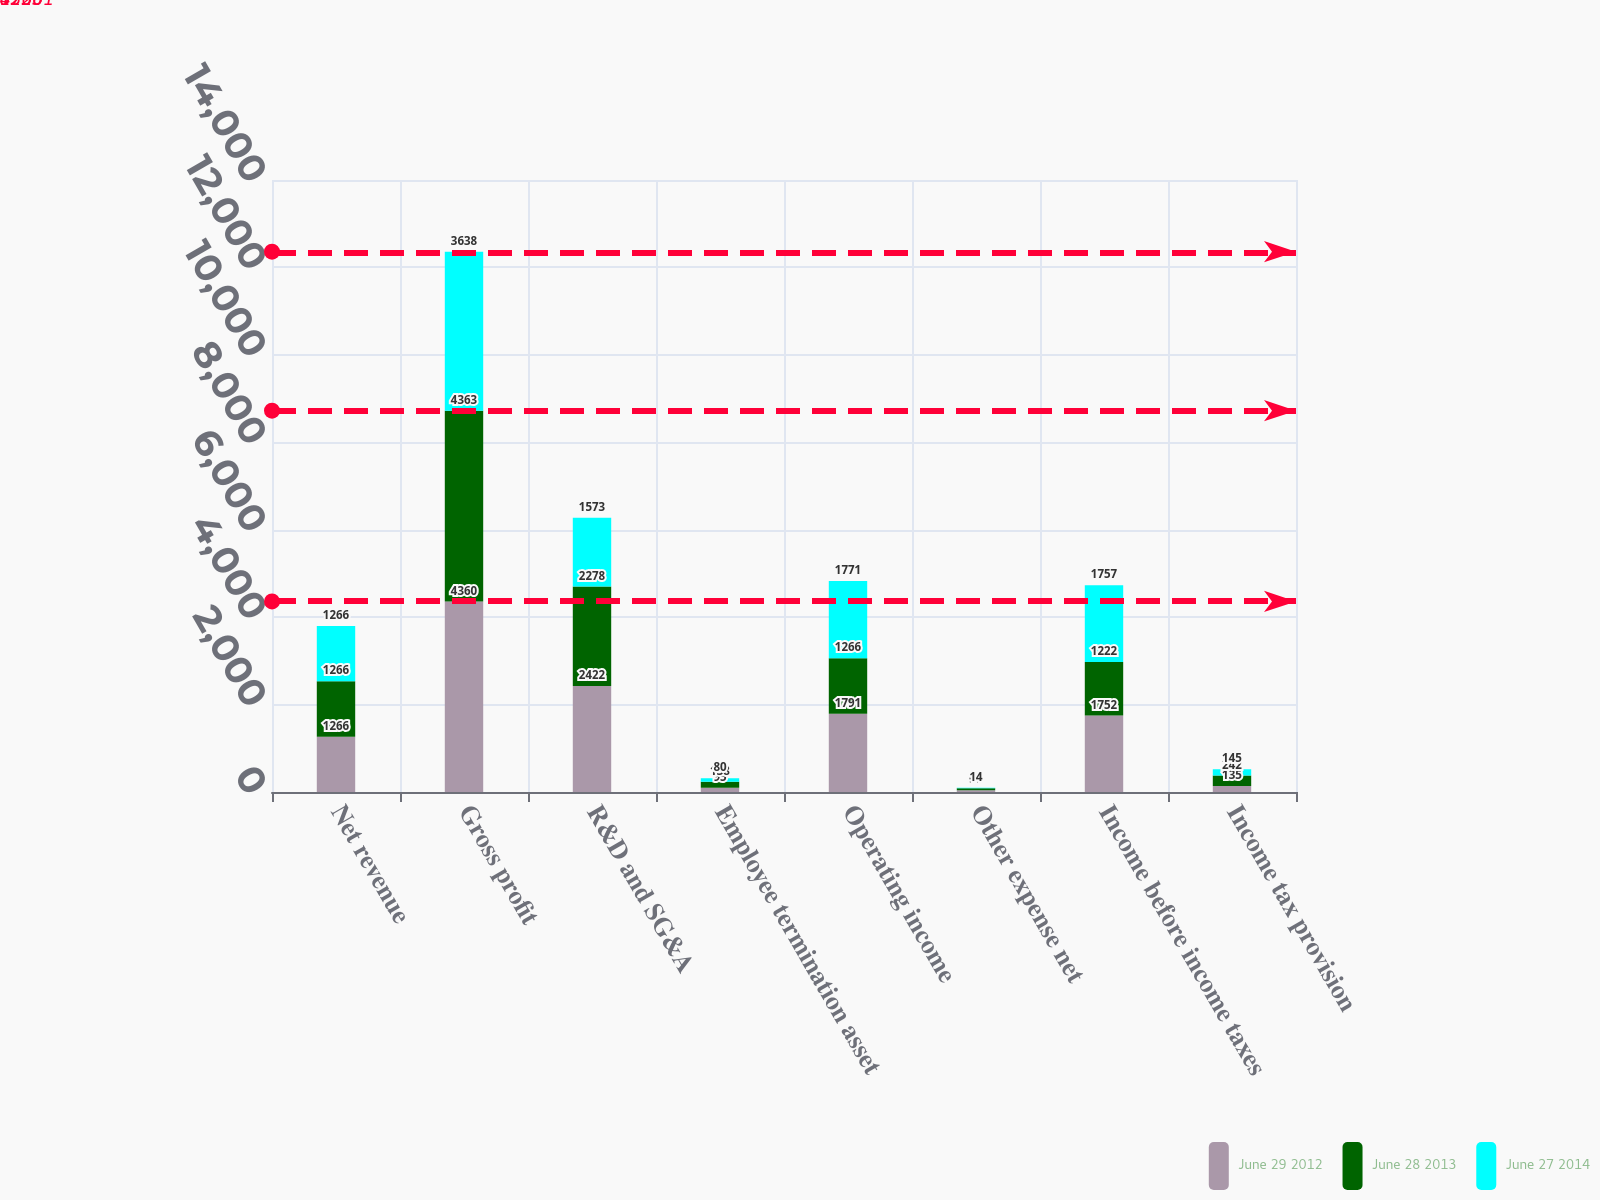<chart> <loc_0><loc_0><loc_500><loc_500><stacked_bar_chart><ecel><fcel>Net revenue<fcel>Gross profit<fcel>R&D and SG&A<fcel>Employee termination asset<fcel>Operating income<fcel>Other expense net<fcel>Income before income taxes<fcel>Income tax provision<nl><fcel>June 29 2012<fcel>1266<fcel>4360<fcel>2422<fcel>95<fcel>1791<fcel>39<fcel>1752<fcel>135<nl><fcel>June 28 2013<fcel>1266<fcel>4363<fcel>2278<fcel>138<fcel>1266<fcel>44<fcel>1222<fcel>242<nl><fcel>June 27 2014<fcel>1266<fcel>3638<fcel>1573<fcel>80<fcel>1771<fcel>14<fcel>1757<fcel>145<nl></chart> 